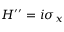<formula> <loc_0><loc_0><loc_500><loc_500>H ^ { \prime \prime } = i \sigma _ { x }</formula> 